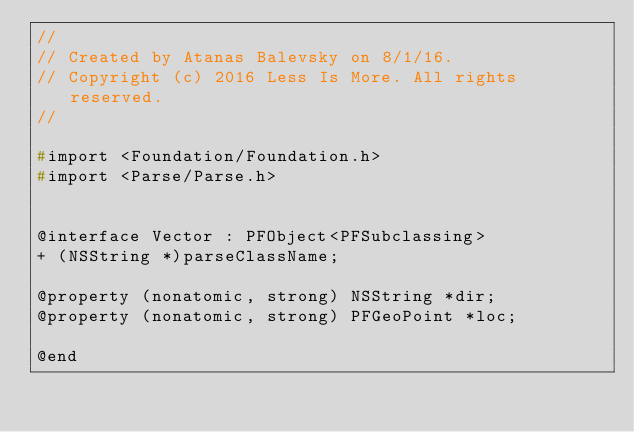<code> <loc_0><loc_0><loc_500><loc_500><_C_>//
// Created by Atanas Balevsky on 8/1/16.
// Copyright (c) 2016 Less Is More. All rights reserved.
//

#import <Foundation/Foundation.h>
#import <Parse/Parse.h>


@interface Vector : PFObject<PFSubclassing>
+ (NSString *)parseClassName;

@property (nonatomic, strong) NSString *dir;
@property (nonatomic, strong) PFGeoPoint *loc;

@end</code> 